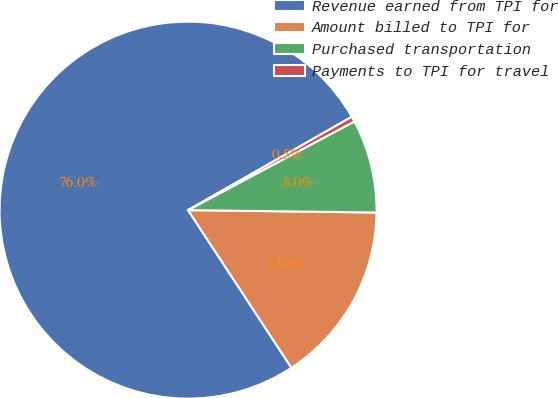<chart> <loc_0><loc_0><loc_500><loc_500><pie_chart><fcel>Revenue earned from TPI for<fcel>Amount billed to TPI for<fcel>Purchased transportation<fcel>Payments to TPI for travel<nl><fcel>75.99%<fcel>15.56%<fcel>8.0%<fcel>0.45%<nl></chart> 